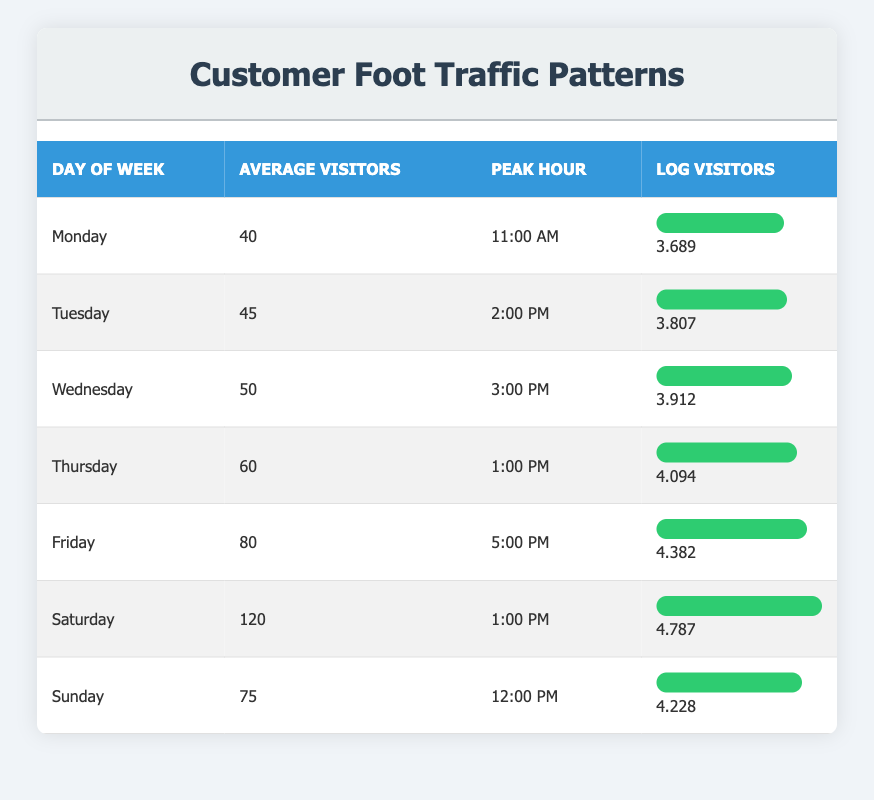What day has the highest average visitors? The data shows that Saturday has the highest average visitors at 120. By comparing the average visitors across all days in the table, it is evident that Saturday surpasses the others.
Answer: Saturday What is the peak hour for Friday? Referring to the table, Friday's peak hour is clearly noted as 5:00 PM, as indicated in the corresponding row under the peak hour column.
Answer: 5:00 PM How many visitors are there on Thursday compared to Monday? Thursday has 60 average visitors and Monday has 40. The difference can be calculated as 60 - 40 = 20, meaning Thursday has 20 more visitors than Monday.
Answer: 20 Is the average number of visitors on Sunday greater than Wednesday? The average number of visitors on Sunday is 75 while on Wednesday it is 50. Since 75 is greater than 50, the answer is yes.
Answer: Yes What is the total average number of visitors from Monday to Thursday? To find the total visitors from Monday to Thursday, we sum their average visitors: 40 (Monday) + 45 (Tuesday) + 50 (Wednesday) + 60 (Thursday) = 195. So, the total is 195.
Answer: 195 Which day has the smallest logarithmic value of visitors? Looking at the log visitors values, Monday's log value is the smallest at 3.689. After reviewing all the logarithmic values in the table, it is clear that Monday has the least.
Answer: Monday If the peak hour for Saturday is 1:00 PM, how does it compare to Friday’s peak hour? Saturday's peak hour is 1:00 PM, while Friday's peak hour is 5:00 PM. To compare these times, 1:00 PM is earlier in the day than 5:00 PM, which indicates that Saturday's visiting trend peaks earlier than Friday's.
Answer: Saturday peaks earlier What is the average number of visitors for the weekend compared to the weekdays? The average for the weekend (Saturday + Sunday) is (120 + 75) / 2 = 97.5. For the weekdays (Monday to Friday), it is (40 + 45 + 50 + 60 + 80) / 5 = 55. 97.5 is greater than 55, so the weekend has more visitors on average.
Answer: Weekend is greater What is the difference in logarithmic visitors between Saturday and Tuesday? Saturday has a log visitors value of 4.787, while Tuesday has 3.807. The difference is calculated as 4.787 - 3.807 = 0.980. Thus, Saturday's logarithmic visitors exceed Tuesday's by approximately 0.980.
Answer: 0.980 